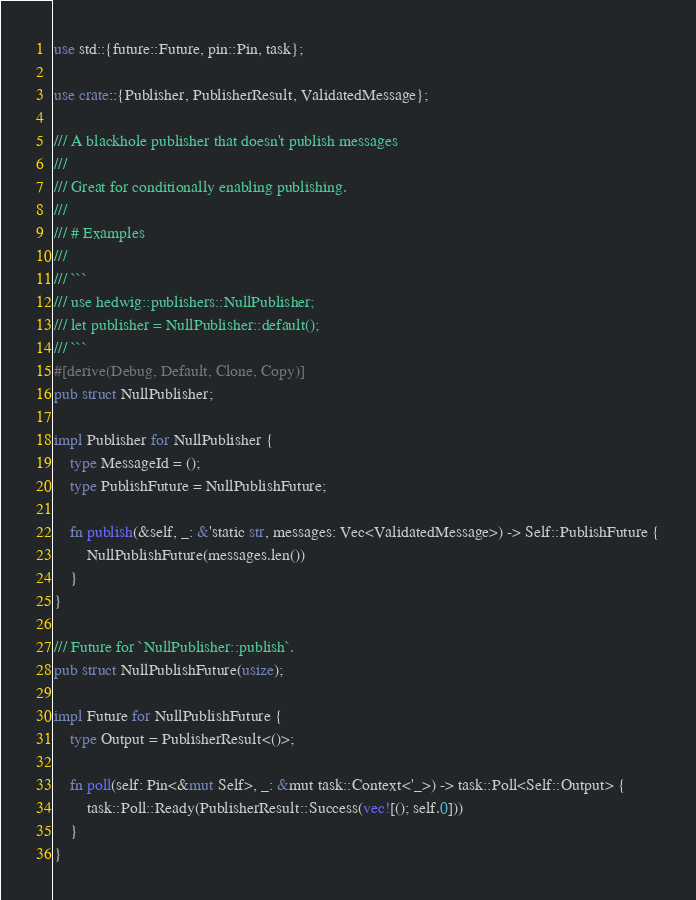Convert code to text. <code><loc_0><loc_0><loc_500><loc_500><_Rust_>use std::{future::Future, pin::Pin, task};

use crate::{Publisher, PublisherResult, ValidatedMessage};

/// A blackhole publisher that doesn't publish messages
///
/// Great for conditionally enabling publishing.
///
/// # Examples
///
/// ```
/// use hedwig::publishers::NullPublisher;
/// let publisher = NullPublisher::default();
/// ```
#[derive(Debug, Default, Clone, Copy)]
pub struct NullPublisher;

impl Publisher for NullPublisher {
    type MessageId = ();
    type PublishFuture = NullPublishFuture;

    fn publish(&self, _: &'static str, messages: Vec<ValidatedMessage>) -> Self::PublishFuture {
        NullPublishFuture(messages.len())
    }
}

/// Future for `NullPublisher::publish`.
pub struct NullPublishFuture(usize);

impl Future for NullPublishFuture {
    type Output = PublisherResult<()>;

    fn poll(self: Pin<&mut Self>, _: &mut task::Context<'_>) -> task::Poll<Self::Output> {
        task::Poll::Ready(PublisherResult::Success(vec![(); self.0]))
    }
}
</code> 